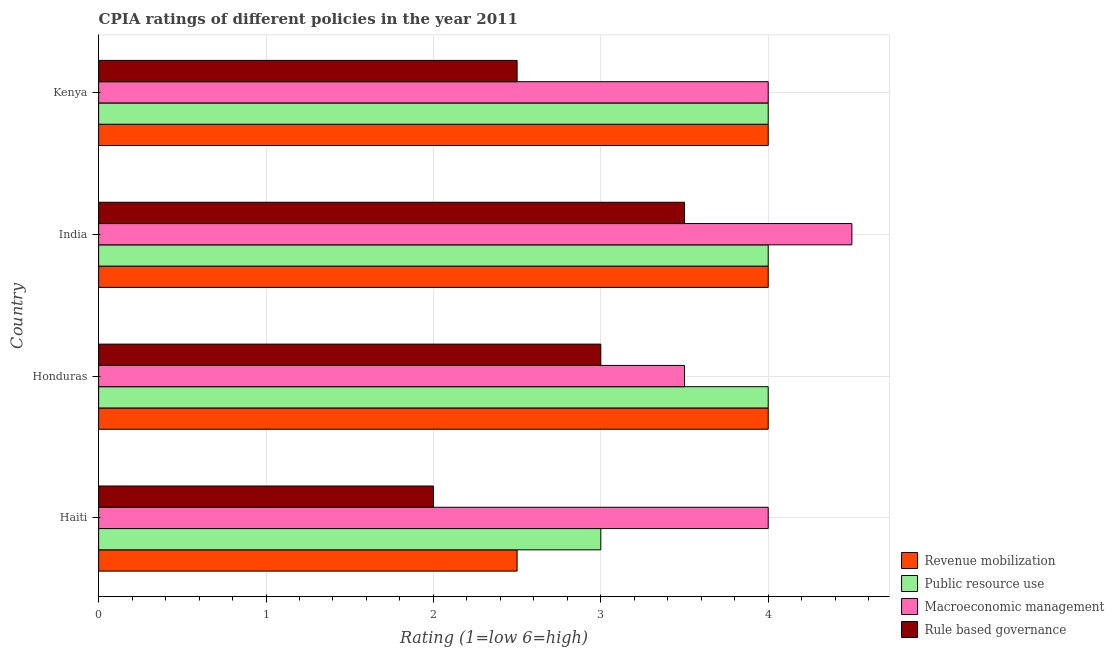Are the number of bars per tick equal to the number of legend labels?
Your answer should be compact. Yes. How many bars are there on the 4th tick from the top?
Your answer should be compact. 4. How many bars are there on the 2nd tick from the bottom?
Keep it short and to the point. 4. What is the label of the 3rd group of bars from the top?
Provide a succinct answer. Honduras. What is the cpia rating of macroeconomic management in Haiti?
Your answer should be compact. 4. Across all countries, what is the minimum cpia rating of public resource use?
Your answer should be compact. 3. In which country was the cpia rating of revenue mobilization maximum?
Offer a very short reply. Honduras. In which country was the cpia rating of macroeconomic management minimum?
Ensure brevity in your answer.  Honduras. What is the difference between the cpia rating of public resource use and cpia rating of revenue mobilization in Honduras?
Ensure brevity in your answer.  0. In how many countries, is the cpia rating of public resource use greater than 3.4 ?
Your response must be concise. 3. What is the ratio of the cpia rating of revenue mobilization in Haiti to that in India?
Give a very brief answer. 0.62. In how many countries, is the cpia rating of rule based governance greater than the average cpia rating of rule based governance taken over all countries?
Provide a short and direct response. 2. Is the sum of the cpia rating of macroeconomic management in Honduras and Kenya greater than the maximum cpia rating of revenue mobilization across all countries?
Offer a terse response. Yes. Is it the case that in every country, the sum of the cpia rating of revenue mobilization and cpia rating of rule based governance is greater than the sum of cpia rating of public resource use and cpia rating of macroeconomic management?
Keep it short and to the point. No. What does the 3rd bar from the top in Honduras represents?
Your response must be concise. Public resource use. What does the 2nd bar from the bottom in Honduras represents?
Your response must be concise. Public resource use. Is it the case that in every country, the sum of the cpia rating of revenue mobilization and cpia rating of public resource use is greater than the cpia rating of macroeconomic management?
Offer a terse response. Yes. How many countries are there in the graph?
Your answer should be compact. 4. Are the values on the major ticks of X-axis written in scientific E-notation?
Offer a very short reply. No. Does the graph contain grids?
Your answer should be very brief. Yes. Where does the legend appear in the graph?
Your response must be concise. Bottom right. How many legend labels are there?
Make the answer very short. 4. What is the title of the graph?
Offer a very short reply. CPIA ratings of different policies in the year 2011. Does "Industry" appear as one of the legend labels in the graph?
Keep it short and to the point. No. What is the label or title of the X-axis?
Keep it short and to the point. Rating (1=low 6=high). What is the Rating (1=low 6=high) in Revenue mobilization in Haiti?
Keep it short and to the point. 2.5. What is the Rating (1=low 6=high) in Rule based governance in Haiti?
Provide a short and direct response. 2. What is the Rating (1=low 6=high) in Revenue mobilization in Honduras?
Provide a succinct answer. 4. What is the Rating (1=low 6=high) in Public resource use in Honduras?
Ensure brevity in your answer.  4. What is the Rating (1=low 6=high) of Revenue mobilization in India?
Provide a short and direct response. 4. What is the Rating (1=low 6=high) in Public resource use in India?
Your response must be concise. 4. What is the Rating (1=low 6=high) of Macroeconomic management in India?
Your answer should be very brief. 4.5. What is the Rating (1=low 6=high) of Rule based governance in India?
Your response must be concise. 3.5. What is the Rating (1=low 6=high) in Revenue mobilization in Kenya?
Your response must be concise. 4. What is the Rating (1=low 6=high) of Public resource use in Kenya?
Offer a very short reply. 4. What is the Rating (1=low 6=high) in Macroeconomic management in Kenya?
Ensure brevity in your answer.  4. What is the Rating (1=low 6=high) of Rule based governance in Kenya?
Make the answer very short. 2.5. Across all countries, what is the maximum Rating (1=low 6=high) in Revenue mobilization?
Give a very brief answer. 4. Across all countries, what is the maximum Rating (1=low 6=high) of Public resource use?
Your answer should be very brief. 4. Across all countries, what is the minimum Rating (1=low 6=high) in Public resource use?
Your answer should be very brief. 3. Across all countries, what is the minimum Rating (1=low 6=high) in Macroeconomic management?
Ensure brevity in your answer.  3.5. What is the total Rating (1=low 6=high) in Macroeconomic management in the graph?
Provide a succinct answer. 16. What is the total Rating (1=low 6=high) of Rule based governance in the graph?
Keep it short and to the point. 11. What is the difference between the Rating (1=low 6=high) in Public resource use in Haiti and that in Honduras?
Your answer should be compact. -1. What is the difference between the Rating (1=low 6=high) in Macroeconomic management in Haiti and that in India?
Offer a terse response. -0.5. What is the difference between the Rating (1=low 6=high) of Rule based governance in Haiti and that in India?
Offer a terse response. -1.5. What is the difference between the Rating (1=low 6=high) in Rule based governance in Haiti and that in Kenya?
Your answer should be very brief. -0.5. What is the difference between the Rating (1=low 6=high) in Macroeconomic management in Honduras and that in India?
Give a very brief answer. -1. What is the difference between the Rating (1=low 6=high) in Revenue mobilization in Honduras and that in Kenya?
Offer a very short reply. 0. What is the difference between the Rating (1=low 6=high) in Public resource use in Honduras and that in Kenya?
Your answer should be compact. 0. What is the difference between the Rating (1=low 6=high) in Revenue mobilization in India and that in Kenya?
Make the answer very short. 0. What is the difference between the Rating (1=low 6=high) in Public resource use in India and that in Kenya?
Your answer should be very brief. 0. What is the difference between the Rating (1=low 6=high) of Macroeconomic management in India and that in Kenya?
Make the answer very short. 0.5. What is the difference between the Rating (1=low 6=high) of Revenue mobilization in Haiti and the Rating (1=low 6=high) of Public resource use in Honduras?
Make the answer very short. -1.5. What is the difference between the Rating (1=low 6=high) of Revenue mobilization in Haiti and the Rating (1=low 6=high) of Macroeconomic management in Honduras?
Ensure brevity in your answer.  -1. What is the difference between the Rating (1=low 6=high) of Revenue mobilization in Haiti and the Rating (1=low 6=high) of Rule based governance in Honduras?
Provide a short and direct response. -0.5. What is the difference between the Rating (1=low 6=high) in Macroeconomic management in Haiti and the Rating (1=low 6=high) in Rule based governance in India?
Give a very brief answer. 0.5. What is the difference between the Rating (1=low 6=high) in Revenue mobilization in Haiti and the Rating (1=low 6=high) in Macroeconomic management in Kenya?
Provide a short and direct response. -1.5. What is the difference between the Rating (1=low 6=high) of Public resource use in Haiti and the Rating (1=low 6=high) of Macroeconomic management in Kenya?
Make the answer very short. -1. What is the difference between the Rating (1=low 6=high) of Public resource use in Haiti and the Rating (1=low 6=high) of Rule based governance in Kenya?
Offer a terse response. 0.5. What is the difference between the Rating (1=low 6=high) in Revenue mobilization in Honduras and the Rating (1=low 6=high) in Public resource use in India?
Keep it short and to the point. 0. What is the difference between the Rating (1=low 6=high) in Revenue mobilization in Honduras and the Rating (1=low 6=high) in Macroeconomic management in India?
Offer a very short reply. -0.5. What is the difference between the Rating (1=low 6=high) in Public resource use in Honduras and the Rating (1=low 6=high) in Macroeconomic management in India?
Ensure brevity in your answer.  -0.5. What is the difference between the Rating (1=low 6=high) in Public resource use in Honduras and the Rating (1=low 6=high) in Rule based governance in India?
Offer a terse response. 0.5. What is the difference between the Rating (1=low 6=high) in Revenue mobilization in Honduras and the Rating (1=low 6=high) in Public resource use in Kenya?
Give a very brief answer. 0. What is the difference between the Rating (1=low 6=high) of Revenue mobilization in Honduras and the Rating (1=low 6=high) of Rule based governance in Kenya?
Keep it short and to the point. 1.5. What is the difference between the Rating (1=low 6=high) of Macroeconomic management in Honduras and the Rating (1=low 6=high) of Rule based governance in Kenya?
Offer a terse response. 1. What is the difference between the Rating (1=low 6=high) of Revenue mobilization in India and the Rating (1=low 6=high) of Macroeconomic management in Kenya?
Offer a terse response. 0. What is the difference between the Rating (1=low 6=high) in Revenue mobilization in India and the Rating (1=low 6=high) in Rule based governance in Kenya?
Offer a very short reply. 1.5. What is the difference between the Rating (1=low 6=high) in Public resource use in India and the Rating (1=low 6=high) in Macroeconomic management in Kenya?
Your answer should be compact. 0. What is the difference between the Rating (1=low 6=high) of Public resource use in India and the Rating (1=low 6=high) of Rule based governance in Kenya?
Offer a very short reply. 1.5. What is the difference between the Rating (1=low 6=high) in Macroeconomic management in India and the Rating (1=low 6=high) in Rule based governance in Kenya?
Give a very brief answer. 2. What is the average Rating (1=low 6=high) of Revenue mobilization per country?
Offer a very short reply. 3.62. What is the average Rating (1=low 6=high) of Public resource use per country?
Provide a succinct answer. 3.75. What is the average Rating (1=low 6=high) in Rule based governance per country?
Give a very brief answer. 2.75. What is the difference between the Rating (1=low 6=high) of Revenue mobilization and Rating (1=low 6=high) of Macroeconomic management in Haiti?
Provide a succinct answer. -1.5. What is the difference between the Rating (1=low 6=high) of Revenue mobilization and Rating (1=low 6=high) of Rule based governance in Haiti?
Provide a succinct answer. 0.5. What is the difference between the Rating (1=low 6=high) of Public resource use and Rating (1=low 6=high) of Rule based governance in Haiti?
Offer a terse response. 1. What is the difference between the Rating (1=low 6=high) of Revenue mobilization and Rating (1=low 6=high) of Macroeconomic management in Honduras?
Make the answer very short. 0.5. What is the difference between the Rating (1=low 6=high) of Revenue mobilization and Rating (1=low 6=high) of Rule based governance in Honduras?
Make the answer very short. 1. What is the difference between the Rating (1=low 6=high) of Macroeconomic management and Rating (1=low 6=high) of Rule based governance in Honduras?
Provide a short and direct response. 0.5. What is the difference between the Rating (1=low 6=high) of Revenue mobilization and Rating (1=low 6=high) of Public resource use in India?
Your response must be concise. 0. What is the difference between the Rating (1=low 6=high) of Revenue mobilization and Rating (1=low 6=high) of Macroeconomic management in India?
Keep it short and to the point. -0.5. What is the difference between the Rating (1=low 6=high) of Revenue mobilization and Rating (1=low 6=high) of Rule based governance in India?
Give a very brief answer. 0.5. What is the difference between the Rating (1=low 6=high) in Public resource use and Rating (1=low 6=high) in Macroeconomic management in India?
Your answer should be compact. -0.5. What is the difference between the Rating (1=low 6=high) in Public resource use and Rating (1=low 6=high) in Rule based governance in India?
Make the answer very short. 0.5. What is the difference between the Rating (1=low 6=high) in Revenue mobilization and Rating (1=low 6=high) in Public resource use in Kenya?
Keep it short and to the point. 0. What is the difference between the Rating (1=low 6=high) of Revenue mobilization and Rating (1=low 6=high) of Macroeconomic management in Kenya?
Keep it short and to the point. 0. What is the ratio of the Rating (1=low 6=high) of Public resource use in Haiti to that in India?
Provide a succinct answer. 0.75. What is the ratio of the Rating (1=low 6=high) of Revenue mobilization in Haiti to that in Kenya?
Provide a succinct answer. 0.62. What is the ratio of the Rating (1=low 6=high) of Rule based governance in Haiti to that in Kenya?
Your response must be concise. 0.8. What is the ratio of the Rating (1=low 6=high) of Macroeconomic management in Honduras to that in India?
Make the answer very short. 0.78. What is the ratio of the Rating (1=low 6=high) in Revenue mobilization in India to that in Kenya?
Keep it short and to the point. 1. What is the ratio of the Rating (1=low 6=high) in Public resource use in India to that in Kenya?
Keep it short and to the point. 1. What is the ratio of the Rating (1=low 6=high) in Macroeconomic management in India to that in Kenya?
Your answer should be very brief. 1.12. What is the difference between the highest and the second highest Rating (1=low 6=high) in Public resource use?
Ensure brevity in your answer.  0. What is the difference between the highest and the second highest Rating (1=low 6=high) of Rule based governance?
Your answer should be compact. 0.5. What is the difference between the highest and the lowest Rating (1=low 6=high) of Revenue mobilization?
Your answer should be very brief. 1.5. 